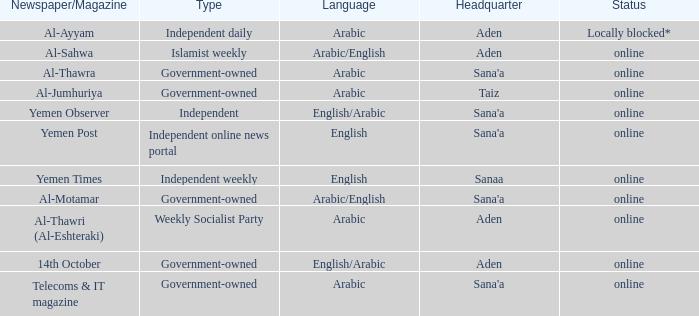Where is the primary base for an independent online news portal? Sana'a. 